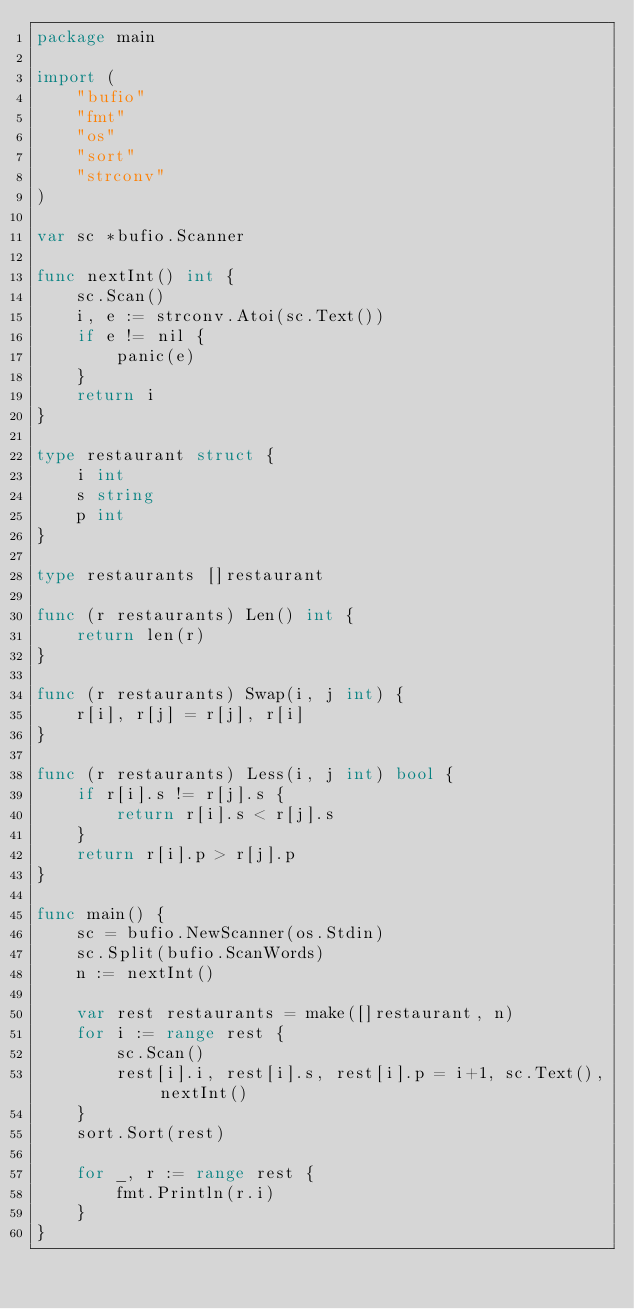Convert code to text. <code><loc_0><loc_0><loc_500><loc_500><_Go_>package main

import (
	"bufio"
	"fmt"
	"os"
	"sort"
	"strconv"
)

var sc *bufio.Scanner

func nextInt() int {
	sc.Scan()
	i, e := strconv.Atoi(sc.Text())
	if e != nil {
		panic(e)
	}
	return i
}

type restaurant struct {
	i int
	s string
	p int
}

type restaurants []restaurant

func (r restaurants) Len() int {
	return len(r)
}

func (r restaurants) Swap(i, j int) {
	r[i], r[j] = r[j], r[i]
}

func (r restaurants) Less(i, j int) bool {
	if r[i].s != r[j].s {
		return r[i].s < r[j].s
	}
	return r[i].p > r[j].p
}

func main() {
	sc = bufio.NewScanner(os.Stdin)
	sc.Split(bufio.ScanWords)
	n := nextInt()

	var rest restaurants = make([]restaurant, n)
	for i := range rest {
		sc.Scan()
		rest[i].i, rest[i].s, rest[i].p = i+1, sc.Text(), nextInt()
	}
	sort.Sort(rest)

	for _, r := range rest {
		fmt.Println(r.i)
	}
}
</code> 